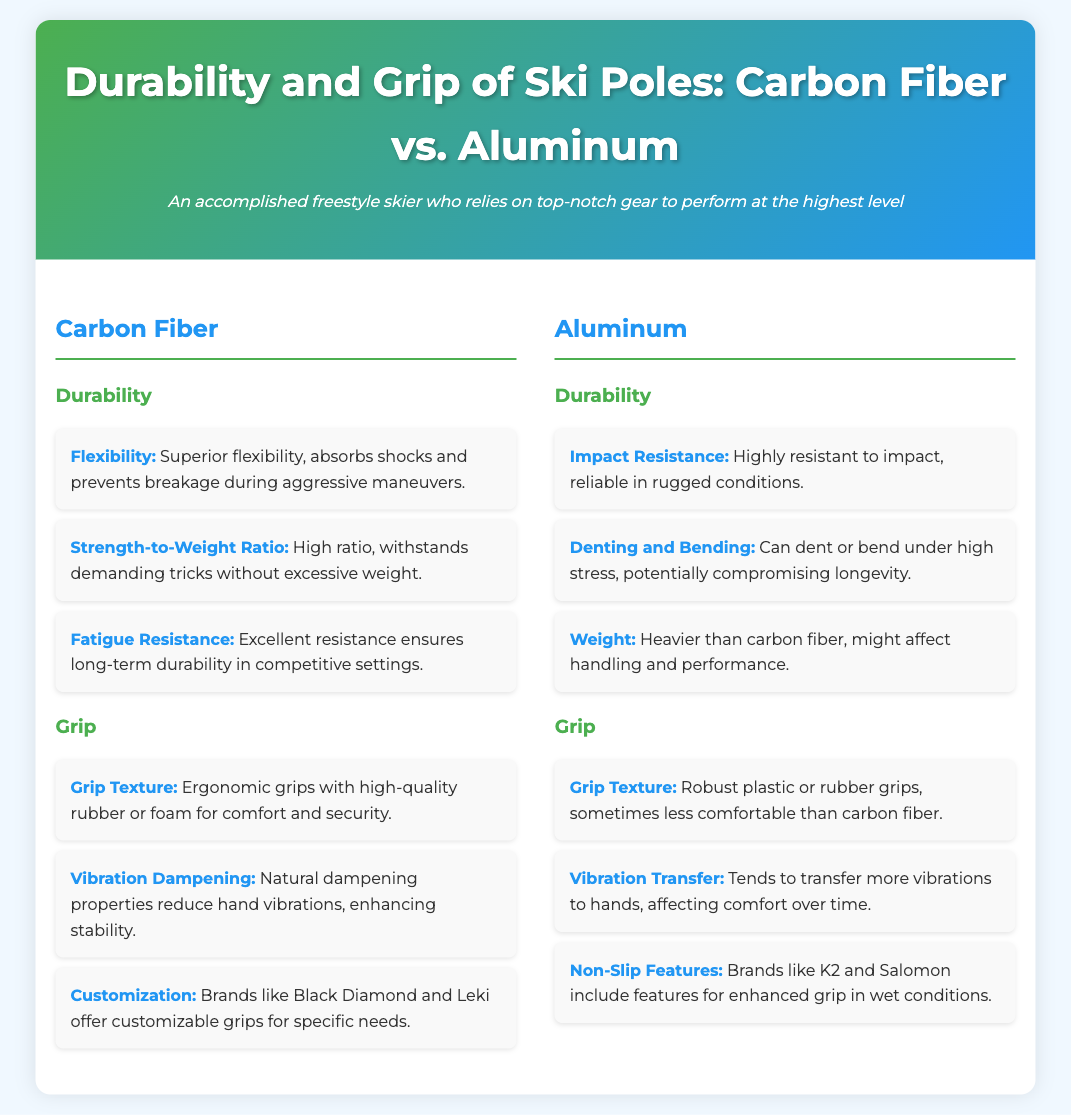What is the flexibility advantage of carbon fiber ski poles? Carbon fiber ski poles have superior flexibility, which absorbs shocks and prevents breakage during aggressive maneuvers.
Answer: Superior flexibility How do aluminum ski poles handle impact? Aluminum ski poles are highly resistant to impact, making them reliable in rugged conditions.
Answer: Highly resistant What feature enhances stability in carbon fiber ski poles? The natural dampening properties of carbon fiber reduce hand vibrations, enhancing stability.
Answer: Vibration dampening Which brand offers customizable grips for carbon fiber ski poles? Brands like Black Diamond and Leki provide customizable grips tailored for specific needs.
Answer: Black Diamond and Leki How does the weight of aluminum ski poles compare to carbon fiber? Aluminum ski poles are heavier than carbon fiber, which can affect handling and performance.
Answer: Heavier What type of grip texture do aluminum ski poles typically use? Aluminum ski poles often have robust plastic or rubber grips, which can be less comfortable than those on carbon fiber poles.
Answer: Robust plastic or rubber grips 